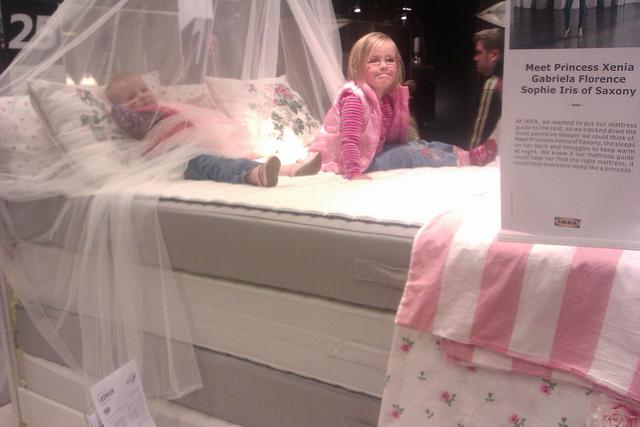Why is there a sign on the bed? Please explain your reasoning. to sell. On the very bottom of the sign is the name ikea. this bed can be found in the store and can be taking home after purchase. 